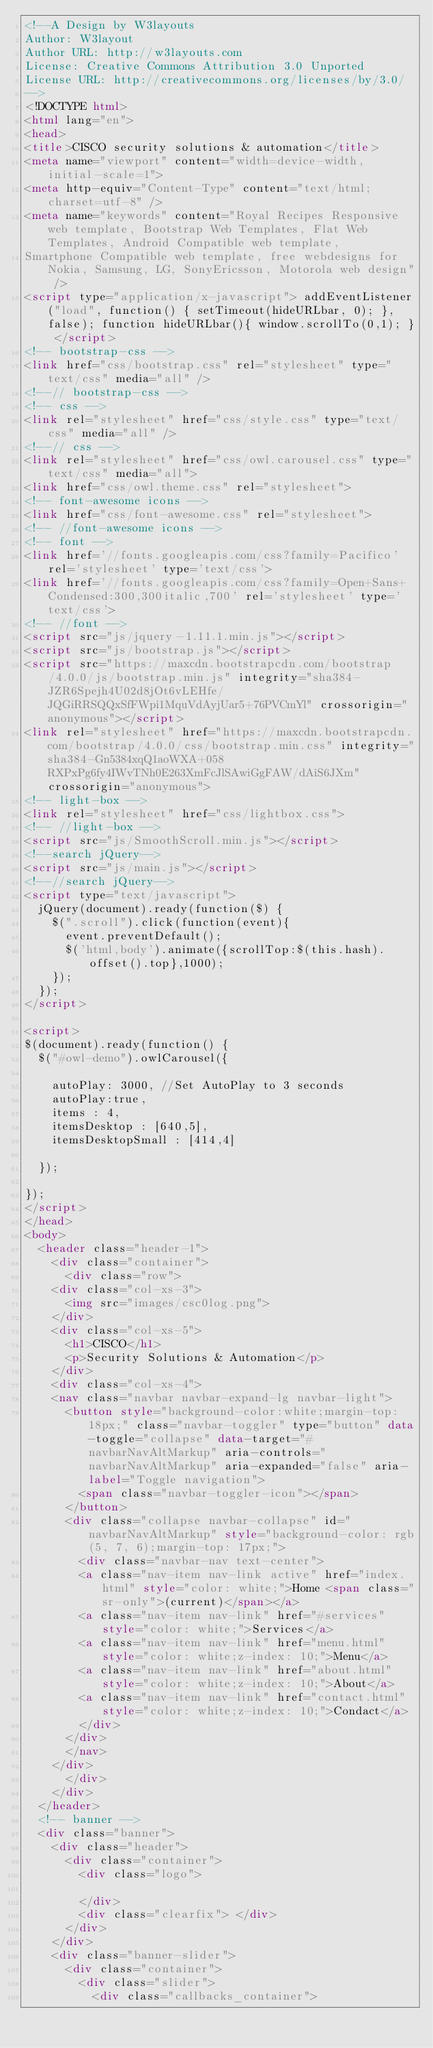Convert code to text. <code><loc_0><loc_0><loc_500><loc_500><_HTML_><!--A Design by W3layouts
Author: W3layout
Author URL: http://w3layouts.com
License: Creative Commons Attribution 3.0 Unported
License URL: http://creativecommons.org/licenses/by/3.0/
-->
<!DOCTYPE html>
<html lang="en">
<head>
<title>CISCO security solutions & automation</title>
<meta name="viewport" content="width=device-width, initial-scale=1">
<meta http-equiv="Content-Type" content="text/html; charset=utf-8" />
<meta name="keywords" content="Royal Recipes Responsive web template, Bootstrap Web Templates, Flat Web Templates, Android Compatible web template, 
Smartphone Compatible web template, free webdesigns for Nokia, Samsung, LG, SonyEricsson, Motorola web design" />
<script type="application/x-javascript"> addEventListener("load", function() { setTimeout(hideURLbar, 0); }, false); function hideURLbar(){ window.scrollTo(0,1); } </script>
<!-- bootstrap-css -->
<link href="css/bootstrap.css" rel="stylesheet" type="text/css" media="all" />
<!--// bootstrap-css -->
<!-- css -->
<link rel="stylesheet" href="css/style.css" type="text/css" media="all" />
<!--// css -->
<link rel="stylesheet" href="css/owl.carousel.css" type="text/css" media="all">
<link href="css/owl.theme.css" rel="stylesheet">
<!-- font-awesome icons -->
<link href="css/font-awesome.css" rel="stylesheet"> 
<!-- //font-awesome icons -->
<!-- font -->
<link href='//fonts.googleapis.com/css?family=Pacifico' rel='stylesheet' type='text/css'>
<link href='//fonts.googleapis.com/css?family=Open+Sans+Condensed:300,300italic,700' rel='stylesheet' type='text/css'>
<!-- //font -->
<script src="js/jquery-1.11.1.min.js"></script>
<script src="js/bootstrap.js"></script>
<script src="https://maxcdn.bootstrapcdn.com/bootstrap/4.0.0/js/bootstrap.min.js" integrity="sha384-JZR6Spejh4U02d8jOt6vLEHfe/JQGiRRSQQxSfFWpi1MquVdAyjUar5+76PVCmYl" crossorigin="anonymous"></script>
<link rel="stylesheet" href="https://maxcdn.bootstrapcdn.com/bootstrap/4.0.0/css/bootstrap.min.css" integrity="sha384-Gn5384xqQ1aoWXA+058RXPxPg6fy4IWvTNh0E263XmFcJlSAwiGgFAW/dAiS6JXm" crossorigin="anonymous">
<!-- light-box -->
<link rel="stylesheet" href="css/lightbox.css">
<!-- //light-box -->
<script src="js/SmoothScroll.min.js"></script>
<!--search jQuery-->
<script src="js/main.js"></script>
<!--//search jQuery-->
<script type="text/javascript">
	jQuery(document).ready(function($) {
		$(".scroll").click(function(event){		
			event.preventDefault();
			$('html,body').animate({scrollTop:$(this.hash).offset().top},1000);
		});
	});
</script>

<script>
$(document).ready(function() { 
	$("#owl-demo").owlCarousel({
 
		autoPlay: 3000, //Set AutoPlay to 3 seconds
		autoPlay:true,
		items : 4,
		itemsDesktop : [640,5],
		itemsDesktopSmall : [414,4]
 
	});
	
}); 
</script>
</head>
<body>
	<header class="header-1">
		<div class="container">
			<div class="row">
		<div class="col-xs-3">
			<img src="images/csc0log.png">
		</div>
		<div class="col-xs-5">
			<h1>CISCO</h1>
			<p>Security Solutions & Automation</p>
		</div>
		<div class="col-xs-4">
		<nav class="navbar navbar-expand-lg navbar-light">
			<button style="background-color:white;margin-top: 18px;" class="navbar-toggler" type="button" data-toggle="collapse" data-target="#navbarNavAltMarkup" aria-controls="navbarNavAltMarkup" aria-expanded="false" aria-label="Toggle navigation">
			  <span class="navbar-toggler-icon"></span>
			</button>
			<div class="collapse navbar-collapse" id="navbarNavAltMarkup" style="background-color: rgb(5, 7, 6);margin-top: 17px;">
			  <div class="navbar-nav text-center">
				<a class="nav-item nav-link active" href="index.html" style="color: white;">Home <span class="sr-only">(current)</span></a>
				<a class="nav-item nav-link" href="#services" style="color: white;">Services</a>
				<a class="nav-item nav-link" href="menu.html" style="color: white;z-index: 10;">Menu</a>
				<a class="nav-item nav-link" href="about.html" style="color: white;z-index: 10;">About</a>
				<a class="nav-item nav-link" href="contact.html" style="color: white;z-index: 10;">Condact</a>
			  </div>
			</div>
		  </nav>
		</div>
			</div>
		</div>
	</header>
	<!-- banner -->
	<div class="banner">
		<div class="header">
			<div class="container">
				<div class="logo">
					
				</div>
				<div class="clearfix"> </div>
			</div>
		</div>
		<div class="banner-slider">
			<div class="container">
				<div class="slider">
					<div class="callbacks_container"></code> 